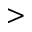Convert formula to latex. <formula><loc_0><loc_0><loc_500><loc_500>></formula> 